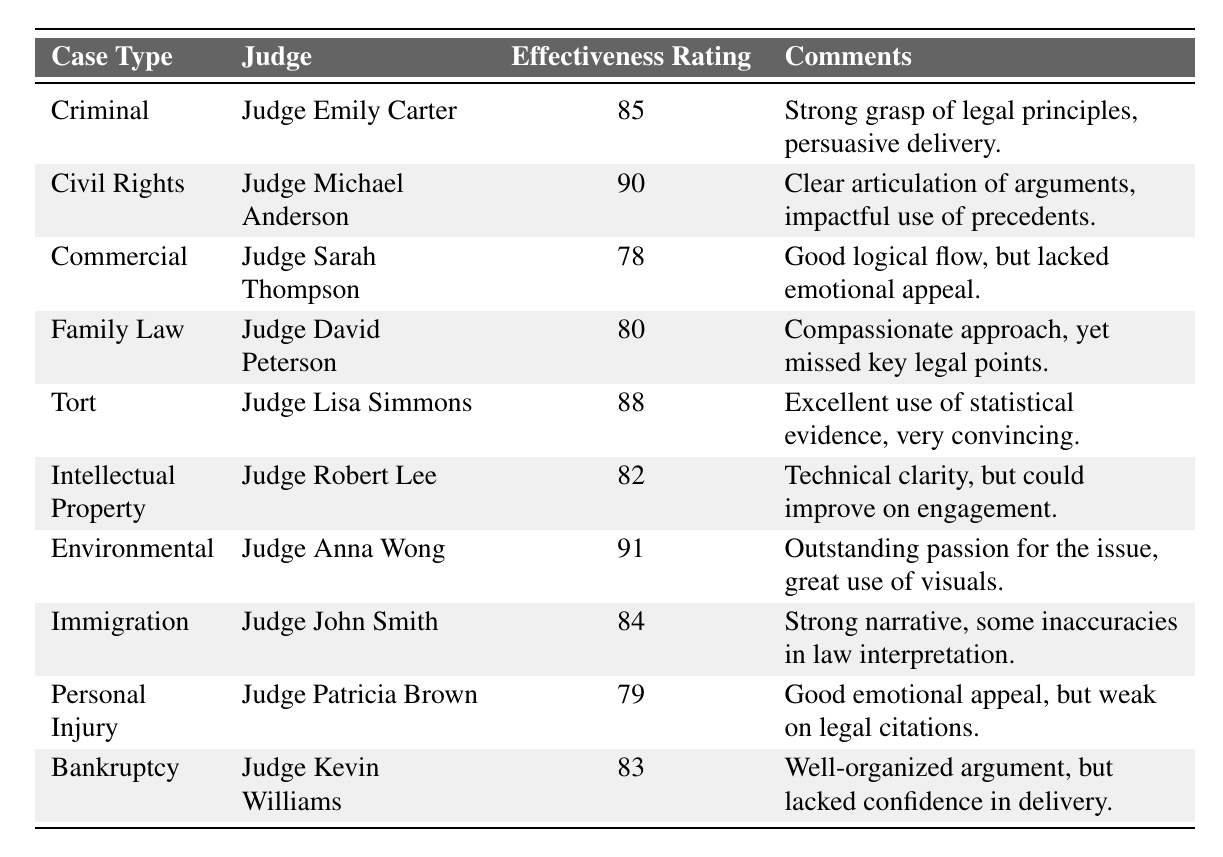What is the highest effectiveness rating and which judge received it? The table lists various judges and their effectiveness ratings. Scanning through the ratings, the highest value is 91, which is associated with Judge Anna Wong in the Environmental case type.
Answer: 91, Judge Anna Wong Which judge had the lowest effectiveness rating? Looking through the table, Judge Sarah Thompson has the lowest rating of 78 in the Commercial case type.
Answer: Judge Sarah Thompson What is the average effectiveness rating for all judges listed? To find the average, sum all the effectiveness ratings: 85 + 90 + 78 + 80 + 88 + 82 + 91 + 84 + 79 + 83 =  84.6. Then, divide by the number of judges (10): 846 / 10 = 84.6.
Answer: 84.6 Is Judge Emily Carter's effectiveness rating greater than 80? Checking the table, Judge Emily Carter's rating is 85, which is greater than 80.
Answer: Yes Which case type has the highest effectiveness rating and what is its value? The table shows that the Environmental case type has the highest effectiveness rating of 91, delivered by Judge Anna Wong.
Answer: Environmental, 91 How many judges received a rating of 80 or higher? By analyzing the effectiveness ratings, we find that the judges with ratings of 80 or higher are Judge Emily Carter (85), Judge Michael Anderson (90), Judge Lisa Simmons (88), Judge David Peterson (80), Judge Robert Lee (82), Judge Anna Wong (91), Judge John Smith (84), and Judge Kevin Williams (83). This gives us a total of 8 judges.
Answer: 8 What is the difference between the highest and lowest effectiveness ratings? The highest effectiveness rating is 91 (Judge Anna Wong), and the lowest is 78 (Judge Sarah Thompson). The difference is calculated as 91 - 78 = 13.
Answer: 13 Did Judge Patricia Brown receive a higher effectiveness rating than Judge Robert Lee? According to the table, Judge Patricia Brown's rating is 79, while Judge Robert Lee's is 82. Since 79 is not higher than 82, the answer is no.
Answer: No What was the effectiveness rating of Judge Lisa Simmons in the Tort case type? The table indicates that Judge Lisa Simmons received an effectiveness rating of 88 in the Tort case.
Answer: 88 Which judges received comments related to emotional appeal? The comments for Judge Patricia Brown mention "Good emotional appeal," and for Judge Sarah Thompson, it notes "lacked emotional appeal." Therefore, only Judge Patricia Brown's comments reflect emotional appeal.
Answer: Judge Patricia Brown 